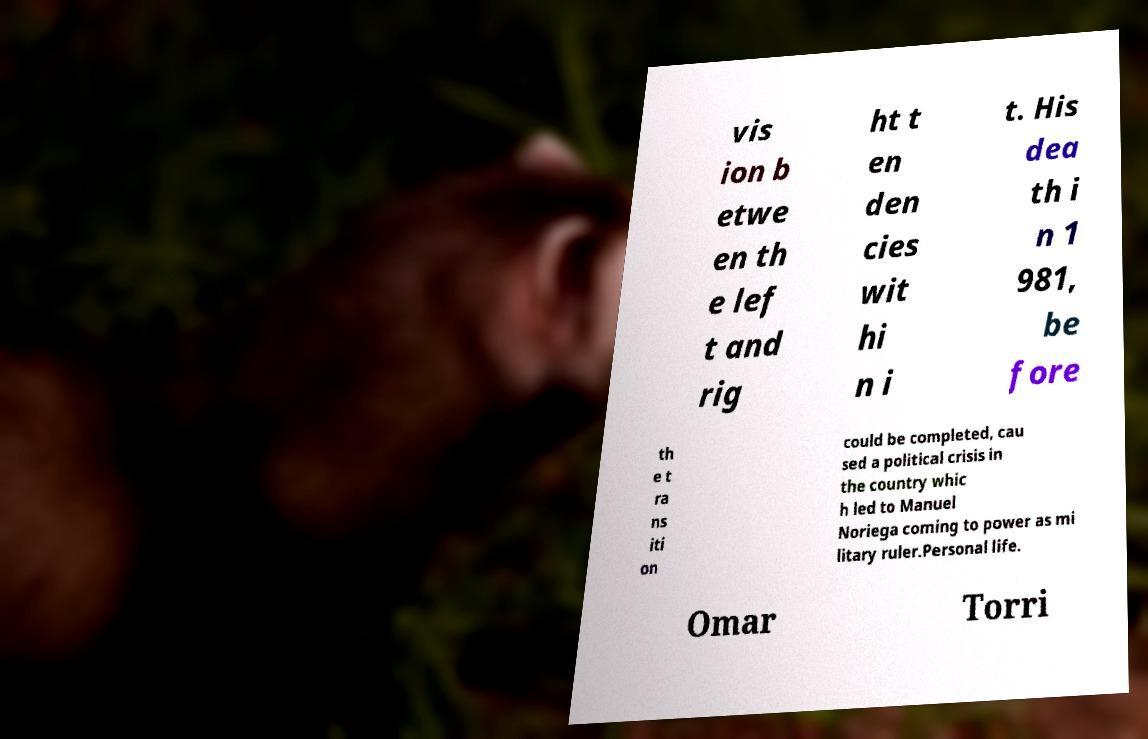What messages or text are displayed in this image? I need them in a readable, typed format. vis ion b etwe en th e lef t and rig ht t en den cies wit hi n i t. His dea th i n 1 981, be fore th e t ra ns iti on could be completed, cau sed a political crisis in the country whic h led to Manuel Noriega coming to power as mi litary ruler.Personal life. Omar Torri 